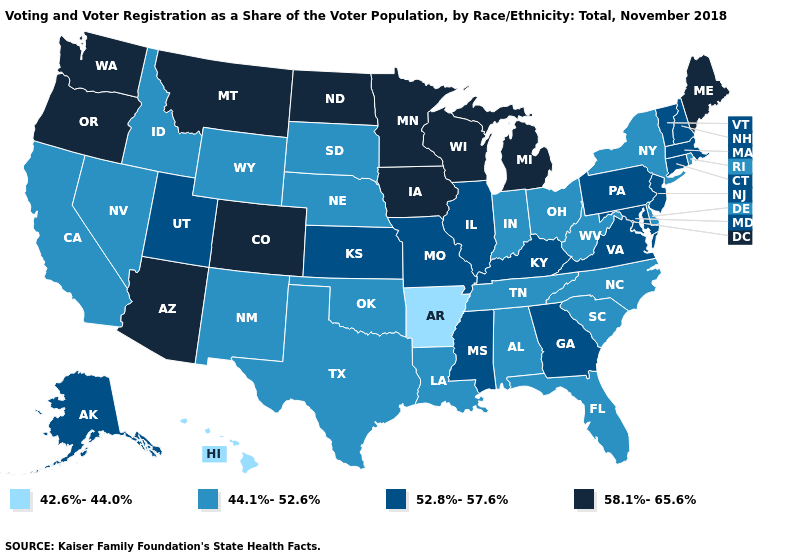Does Alaska have the same value as California?
Be succinct. No. Name the states that have a value in the range 52.8%-57.6%?
Quick response, please. Alaska, Connecticut, Georgia, Illinois, Kansas, Kentucky, Maryland, Massachusetts, Mississippi, Missouri, New Hampshire, New Jersey, Pennsylvania, Utah, Vermont, Virginia. Name the states that have a value in the range 42.6%-44.0%?
Concise answer only. Arkansas, Hawaii. Does the first symbol in the legend represent the smallest category?
Quick response, please. Yes. Does Indiana have the same value as Oregon?
Be succinct. No. What is the highest value in the MidWest ?
Keep it brief. 58.1%-65.6%. Which states have the lowest value in the Northeast?
Write a very short answer. New York, Rhode Island. Which states have the lowest value in the South?
Be succinct. Arkansas. How many symbols are there in the legend?
Quick response, please. 4. What is the lowest value in states that border Washington?
Short answer required. 44.1%-52.6%. Among the states that border Illinois , which have the highest value?
Keep it brief. Iowa, Wisconsin. What is the value of Missouri?
Write a very short answer. 52.8%-57.6%. What is the value of Delaware?
Keep it brief. 44.1%-52.6%. Among the states that border Mississippi , which have the highest value?
Be succinct. Alabama, Louisiana, Tennessee. What is the value of North Carolina?
Concise answer only. 44.1%-52.6%. 